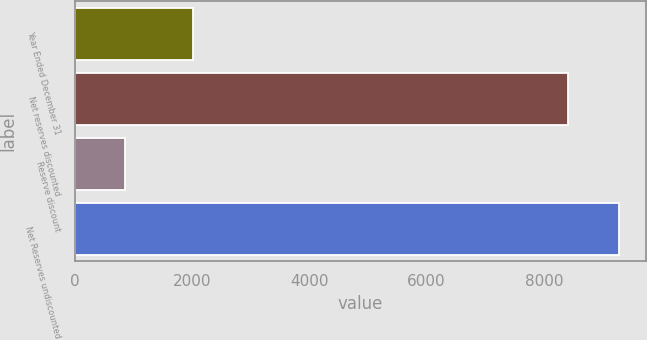<chart> <loc_0><loc_0><loc_500><loc_500><bar_chart><fcel>Year Ended December 31<fcel>Net reserves discounted<fcel>Reserve discount<fcel>Net Reserves undiscounted<nl><fcel>2012<fcel>8412<fcel>867<fcel>9279<nl></chart> 